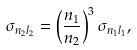Convert formula to latex. <formula><loc_0><loc_0><loc_500><loc_500>\sigma _ { n _ { 2 } l _ { 2 } } = \left ( \frac { n _ { 1 } } { n _ { 2 } } \right ) ^ { 3 } \sigma _ { n _ { 1 } l _ { 1 } } ,</formula> 